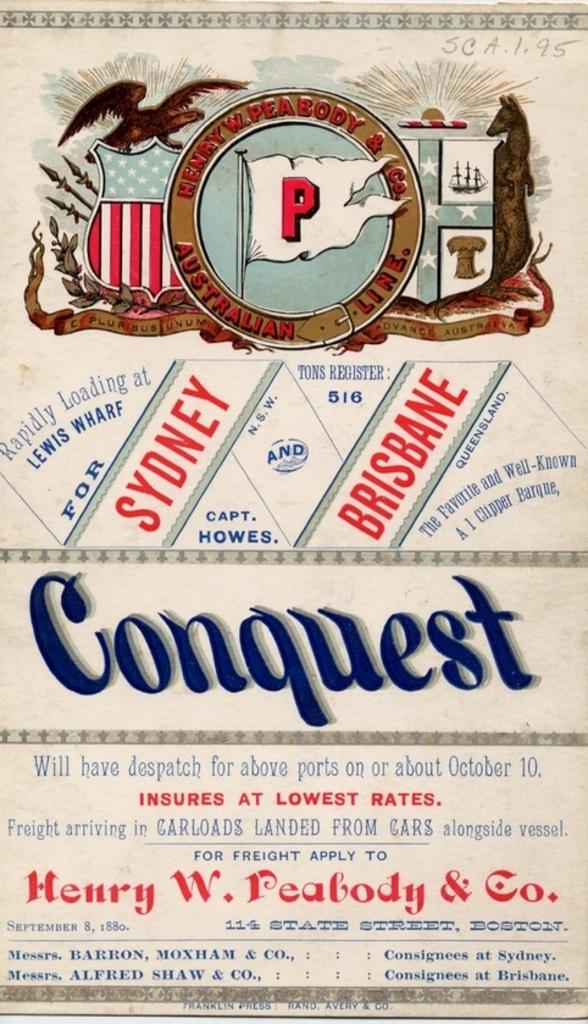<image>
Summarize the visual content of the image. the front cover of the book conquest by henry w realbody. 